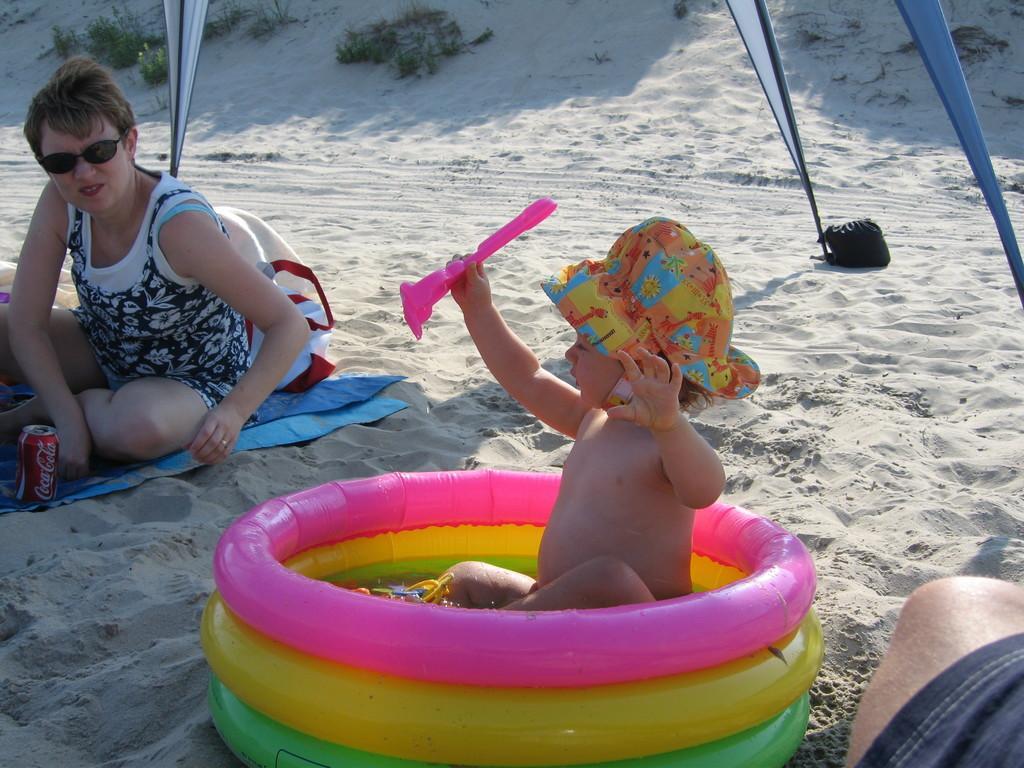How would you summarize this image in a sentence or two? In this image I can see a woman and a child and different colour of tube. I can also see she is wearing shades and in the background I can see grass. 